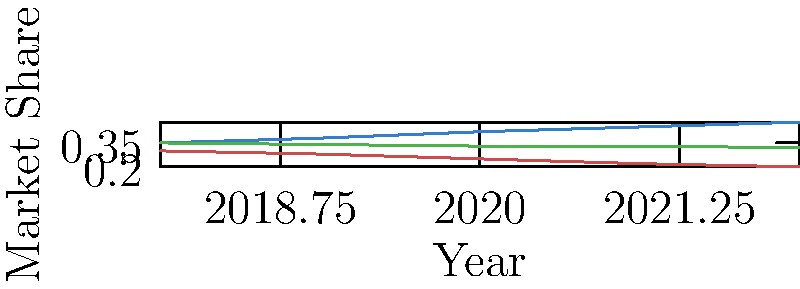Based on the persistence diagram shown, which topological feature of Mallinckrodt's market share trend is most significant, and what does it imply about the company's performance from 2018 to 2022? To answer this question, we need to analyze the persistence diagram, which is represented by the market share trends graph. Let's break it down step-by-step:

1. Observe the trends:
   - Mallinckrodt (blue line) shows a consistent upward trend.
   - Competitor A (red line) shows a consistent downward trend.
   - Competitor B (green line) shows a slight downward trend.

2. Identify topological features:
   - The most significant feature is the persistent upward trend of Mallinckrodt's market share.
   - This trend forms a connected component that persists throughout the entire time period.

3. Analyze the persistence:
   - The upward trend starts at 0.35 in 2018 and continues to 0.48 in 2022.
   - This persistent feature has a long lifespan, existing for the entire 5-year period.

4. Interpret the significance:
   - In topological data analysis, features that persist for longer periods are considered more significant.
   - The long-lasting upward trend indicates a robust and consistent growth in market share.

5. Compare with competitors:
   - Competitor A's downward trend and Competitor B's slight decline further emphasize the significance of Mallinckrodt's growth.

6. Implication for company performance:
   - The persistent upward trend implies that Mallinckrodt has been consistently gaining market share.
   - This suggests strong performance and potential competitive advantages in the pharmaceutical market.

Therefore, the most significant topological feature is the persistent upward trend, implying consistent market share growth and strong performance for Mallinckrodt from 2018 to 2022.
Answer: Persistent upward trend, implying consistent market share growth 